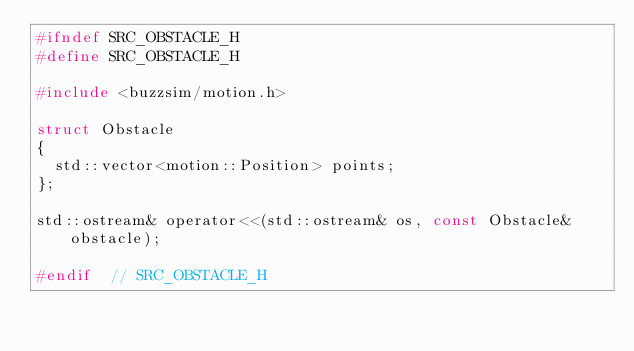Convert code to text. <code><loc_0><loc_0><loc_500><loc_500><_C_>#ifndef SRC_OBSTACLE_H
#define SRC_OBSTACLE_H

#include <buzzsim/motion.h>

struct Obstacle
{
  std::vector<motion::Position> points;
};

std::ostream& operator<<(std::ostream& os, const Obstacle& obstacle);

#endif  // SRC_OBSTACLE_H
</code> 